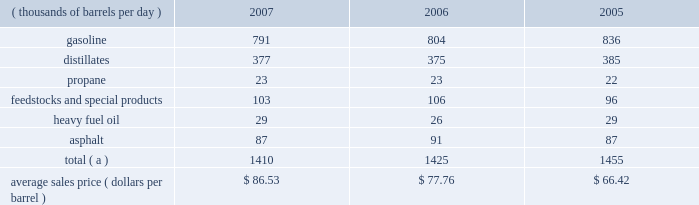Marketing we are a supplier of gasoline and distillates to resellers and consumers within our market area in the midwest , upper great plains , gulf coast and southeastern regions of the united states .
In 2007 , our refined products sales volumes totaled 21.6 billion gallons , or 1.410 mmbpd .
The average sales price of our refined products in aggregate was $ 86.53 per barrel for 2007 .
The table sets forth our refined products sales by product group and our average sales price for each of the last three years .
Refined product sales ( thousands of barrels per day ) 2007 2006 2005 .
Total ( a ) 1410 1425 1455 average sales price ( dollars per barrel ) $ 86.53 $ 77.76 $ 66.42 ( a ) includes matching buy/sell volumes of 24 mbpd and 77 mbpd in 2006 and 2005 .
On april 1 , 2006 , we changed our accounting for matching buy/sell arrangements as a result of a new accounting standard .
This change resulted in lower refined products sales volumes for 2007 and the remainder of 2006 than would have been reported under our previous accounting practices .
See note 2 to the consolidated financial statements .
The wholesale distribution of petroleum products to private brand marketers and to large commercial and industrial consumers and sales in the spot market accounted for 69 percent of our refined products sales volumes in 2007 .
We sold 49 percent of our gasoline volumes and 89 percent of our distillates volumes on a wholesale or spot market basis .
Half of our propane is sold into the home heating market , with the balance being purchased by industrial consumers .
Propylene , cumene , aromatics , aliphatics and sulfur are domestically marketed to customers in the chemical industry .
Base lube oils , maleic anhydride , slack wax , extract and pitch are sold throughout the united states and canada , with pitch products also being exported worldwide .
We market asphalt through owned and leased terminals throughout the midwest , upper great plains , gulf coast and southeastern regions of the united states .
Our customer base includes approximately 750 asphalt-paving contractors , government entities ( states , counties , cities and townships ) and asphalt roofing shingle manufacturers .
We have blended ethanol with gasoline for over 15 years and increased our blending program in 2007 , in part due to renewable fuel mandates .
We blended 41 mbpd of ethanol into gasoline in 2007 and 35 mbpd in both 2006 and 2005 .
The future expansion or contraction of our ethanol blending program will be driven by the economics of the ethanol supply and changes in government regulations .
We sell reformulated gasoline in parts of our marketing territory , primarily chicago , illinois ; louisville , kentucky ; northern kentucky ; milwaukee , wisconsin and hartford , illinois , and we sell low-vapor-pressure gasoline in nine states .
We also sell biodiesel in minnesota , illinois and kentucky .
As of december 31 , 2007 , we supplied petroleum products to about 4400 marathon branded-retail outlets located primarily in ohio , michigan , indiana , kentucky and illinois .
Branded retail outlets are also located in georgia , florida , minnesota , wisconsin , north carolina , tennessee , west virginia , virginia , south carolina , alabama , pennsylvania , and texas .
Sales to marathon-brand jobbers and dealers accounted for 16 percent of our refined product sales volumes in 2007 .
Speedway superamerica llc ( 201cssa 201d ) , our wholly-owned subsidiary , sells gasoline and diesel fuel primarily through retail outlets that we operate .
Sales of refined products through these ssa retail outlets accounted for 15 percent of our refined products sales volumes in 2007 .
As of december 31 , 2007 , ssa had 1636 retail outlets in nine states that sold petroleum products and convenience store merchandise and services , primarily under the brand names 201cspeedway 201d and 201csuperamerica . 201d ssa 2019s revenues from the sale of non-petroleum merchandise totaled $ 2.796 billion in 2007 , compared with $ 2.706 billion in 2006 .
Profit levels from the sale of such merchandise and services tend to be less volatile than profit levels from the retail sale of gasoline and diesel fuel .
Ssa also operates 59 valvoline instant oil change retail outlets located in michigan and northwest ohio .
Pilot travel centers llc ( 201cptc 201d ) , our joint venture with pilot corporation ( 201cpilot 201d ) , is the largest operator of travel centers in the united states with 286 locations in 37 states and canada at december 31 , 2007 .
The travel centers offer diesel fuel , gasoline and a variety of other services , including on-premises brand-name restaurants at many locations .
Pilot and marathon each own a 50 percent interest in ptc. .
What was three year total propane production in mmboe? 
Computations: ((23 + 23) + 22)
Answer: 68.0. 